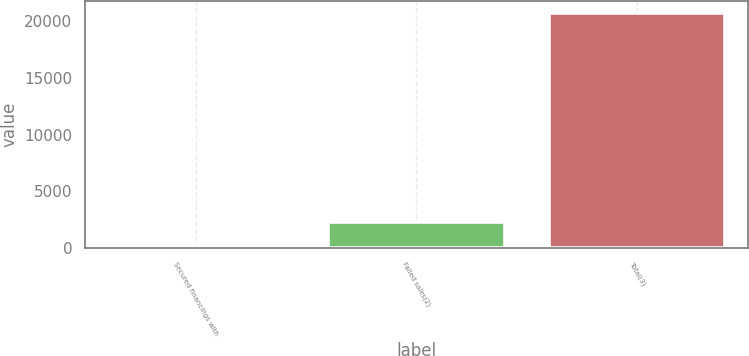<chart> <loc_0><loc_0><loc_500><loc_500><bar_chart><fcel>Secured financings with<fcel>Failed sales(2)<fcel>Total(3)<nl><fcel>275<fcel>2319.4<fcel>20740.4<nl></chart> 